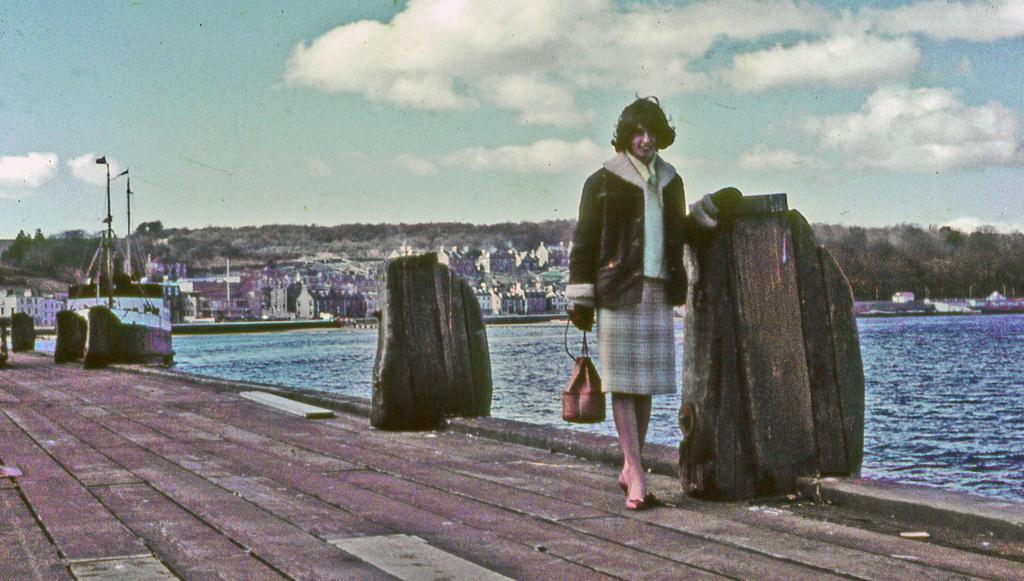Please provide a concise description of this image. This image is taken outdoors. At the top of the image there is the sky with clouds. At the bottom of the image there is a platform. In the background there are many trees and plants. There are a few poles. There are many buildings and houses. There are a few boats on the river. On the right side of the image there is a river with water. On the left side of the image there is a ship on the river. There are a few objects. In the middle of the image a woman is standing on the platform and she is holding a bag in her hand. 